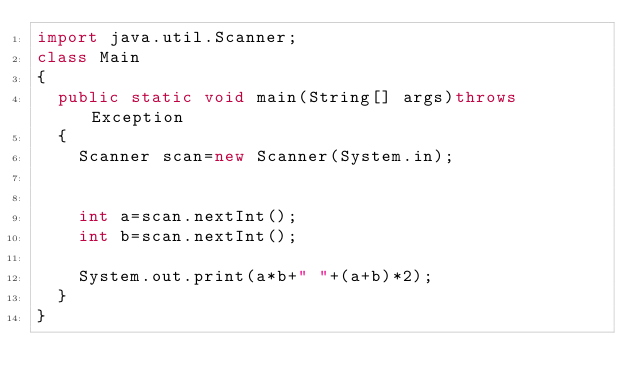Convert code to text. <code><loc_0><loc_0><loc_500><loc_500><_Java_>import java.util.Scanner;
class Main
{
	public static void main(String[] args)throws Exception
	{
		Scanner scan=new Scanner(System.in);
		

		int a=scan.nextInt();
		int b=scan.nextInt();
		
		System.out.print(a*b+" "+(a+b)*2);
	} 
}</code> 